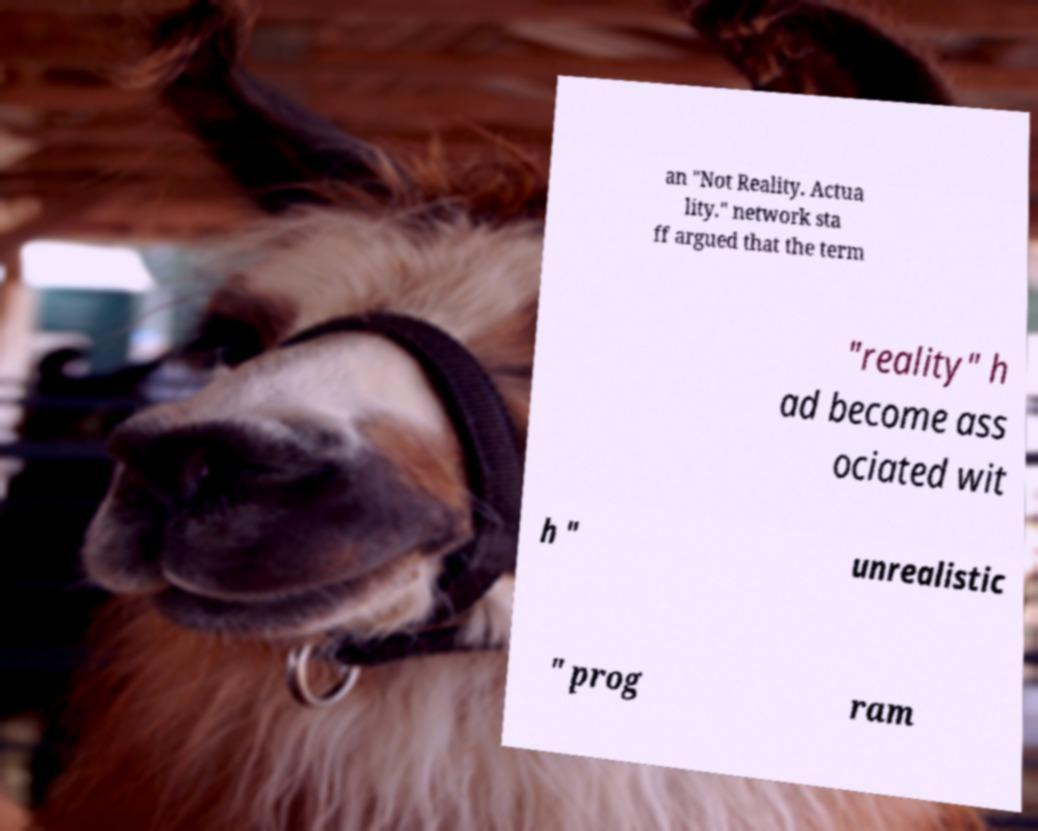Can you read and provide the text displayed in the image?This photo seems to have some interesting text. Can you extract and type it out for me? an "Not Reality. Actua lity." network sta ff argued that the term "reality" h ad become ass ociated wit h " unrealistic " prog ram 